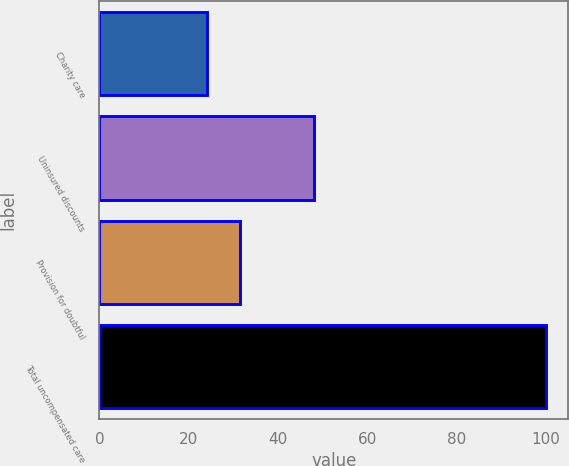Convert chart to OTSL. <chart><loc_0><loc_0><loc_500><loc_500><bar_chart><fcel>Charity care<fcel>Uninsured discounts<fcel>Provision for doubtful<fcel>Total uncompensated care<nl><fcel>24<fcel>48<fcel>31.6<fcel>100<nl></chart> 